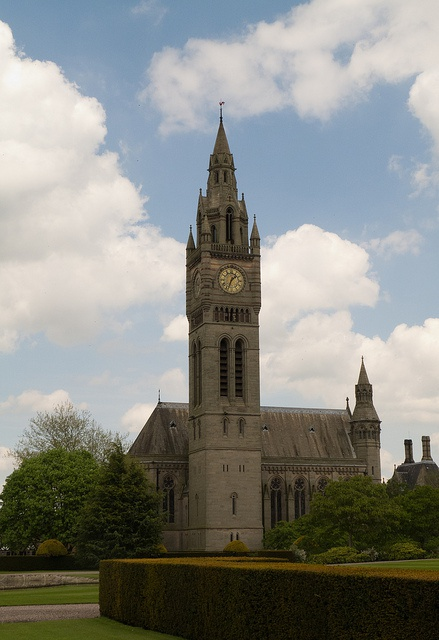Describe the objects in this image and their specific colors. I can see clock in gray, olive, and tan tones and clock in gray and black tones in this image. 